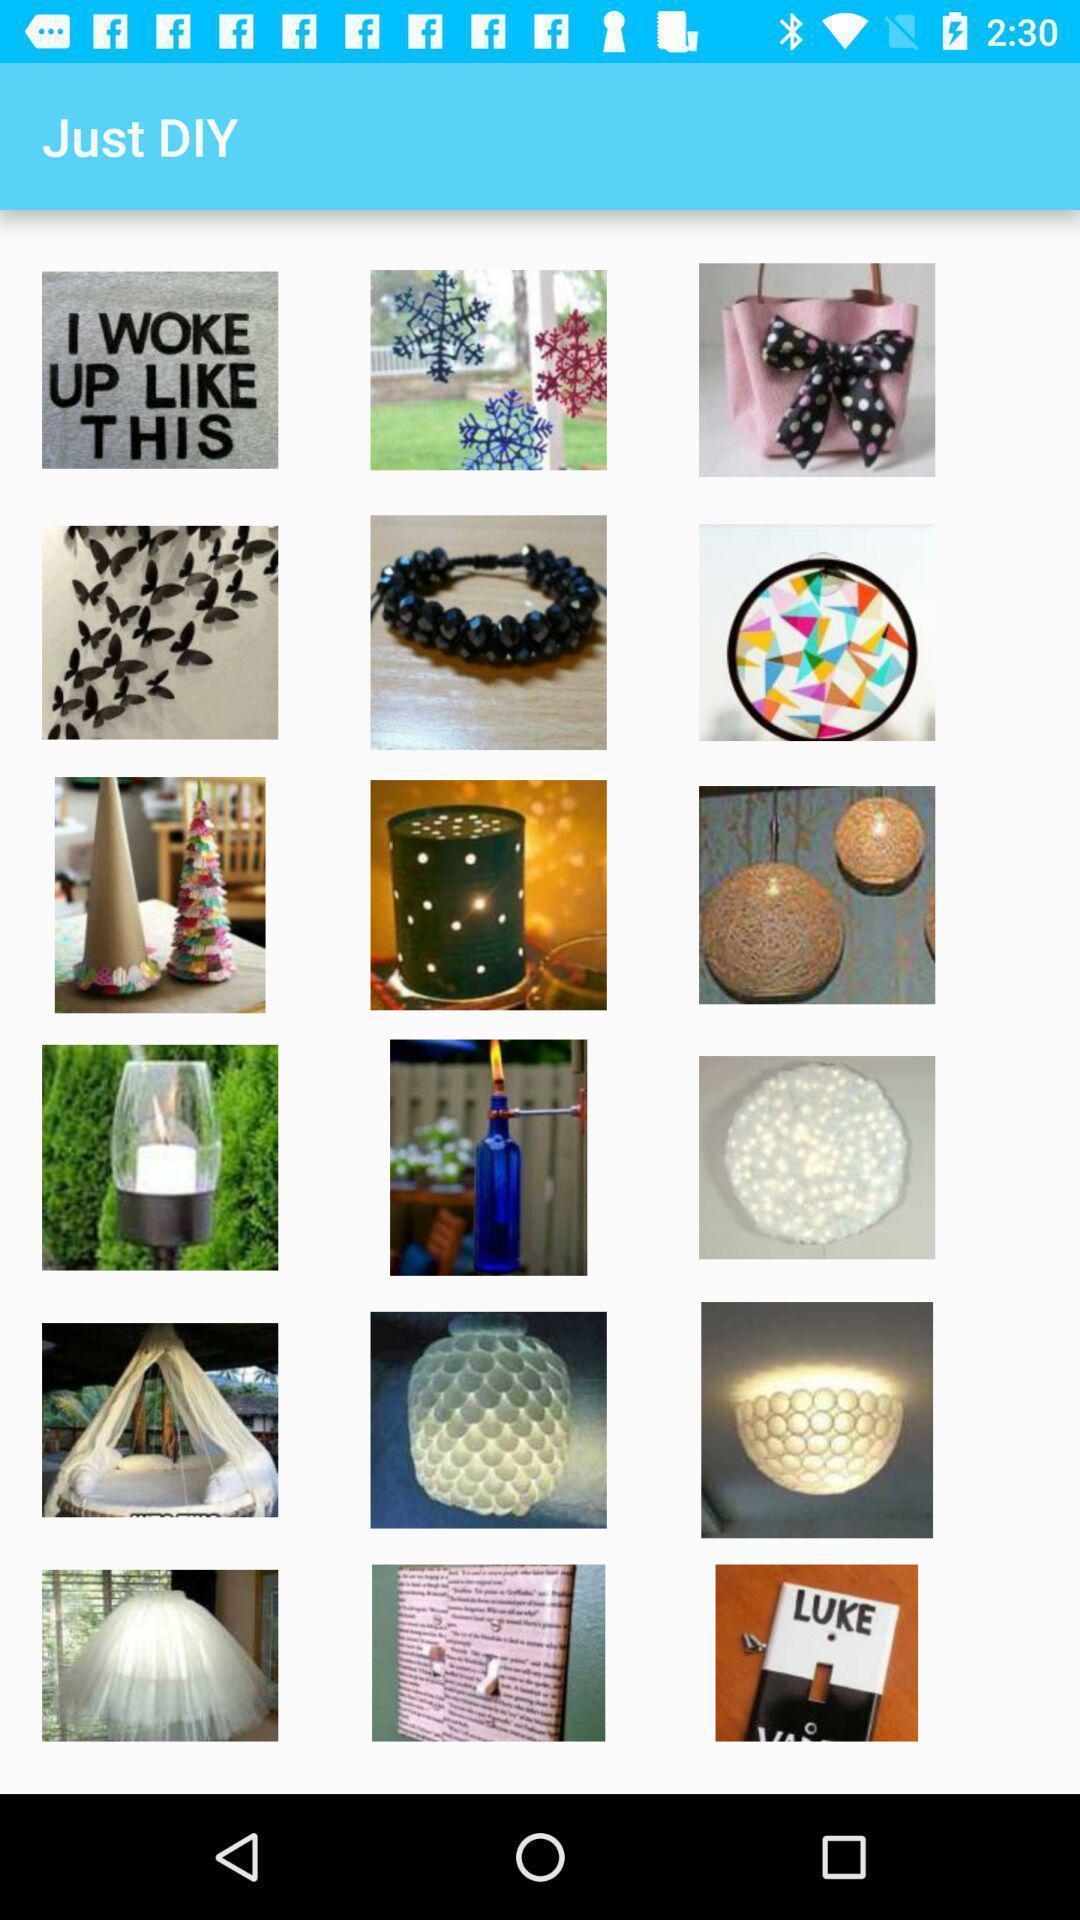Describe the key features of this screenshot. Page showing list of different diy pictures. 